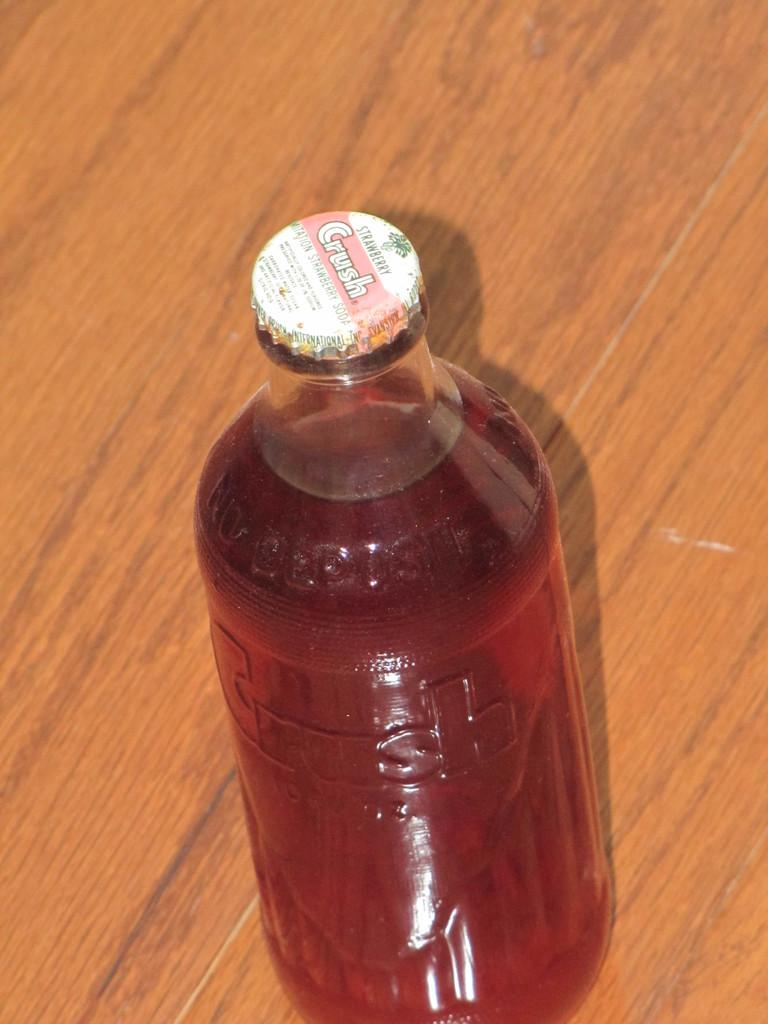<image>
Offer a succinct explanation of the picture presented. A bottle of Crush has a metal cap and is sitting on a wooden table. 